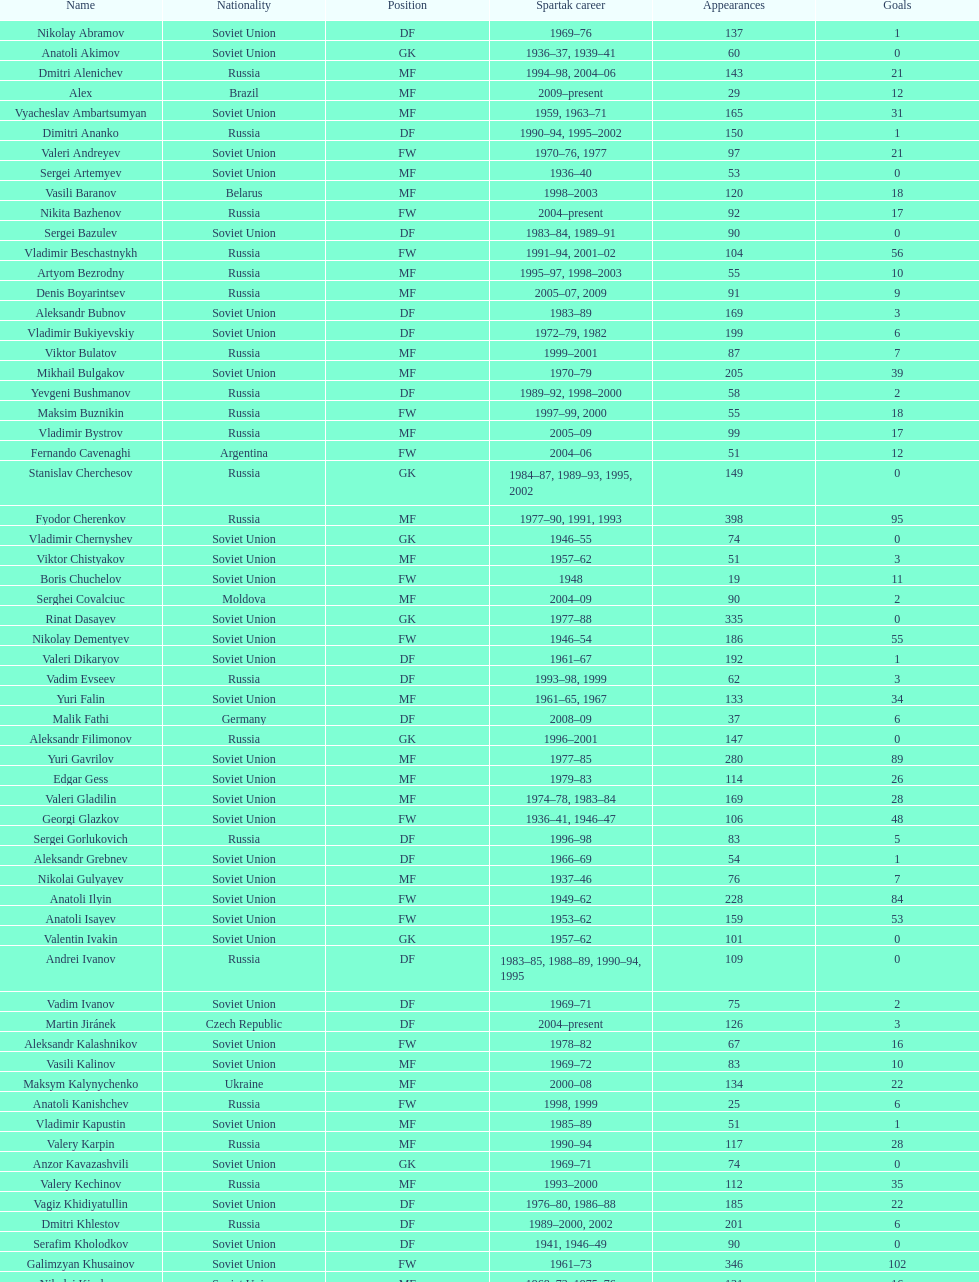Which player has the highest number of goals? Nikita Simonyan. 